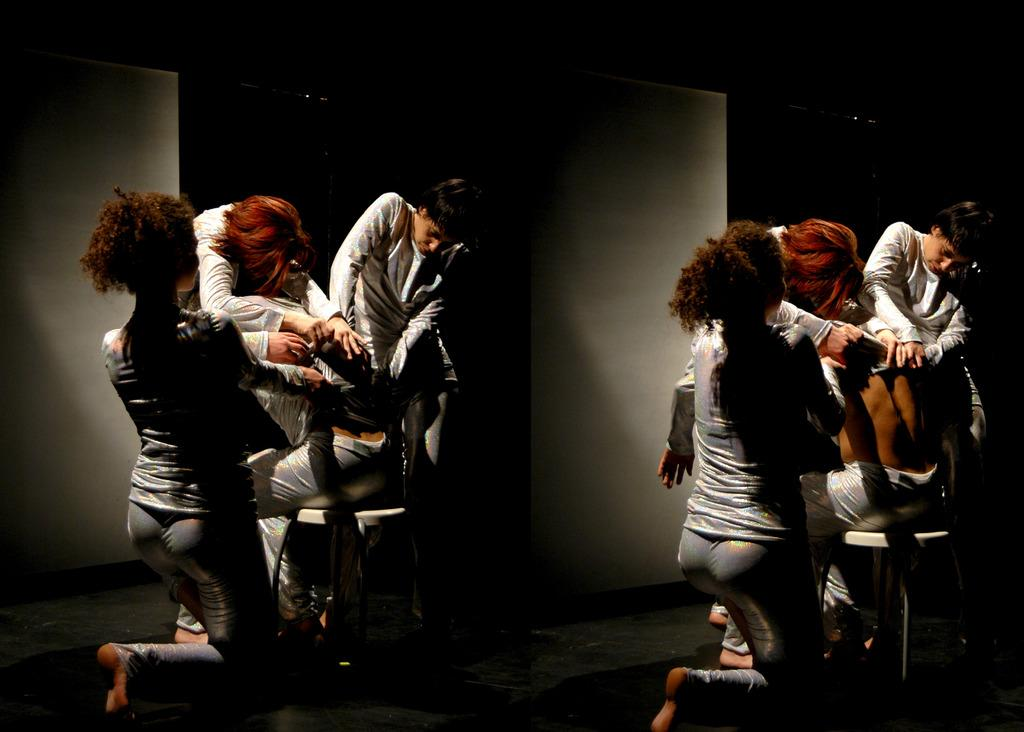How many people are in the room? There are people in the room, but the exact number is not specified. What is one person doing in the room? One person is sitting on a stool. What can be seen in the background of the room? There is a wall in the background. What type of shade is being used to cover the pipe in the room? There is no mention of a pipe or shade in the image, so this question cannot be answered. 